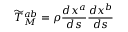<formula> <loc_0><loc_0><loc_500><loc_500>{ \widetilde { T } } _ { M } ^ { a b } = \rho { \frac { d x ^ { a } } { d s } } { \frac { d x ^ { b } } { d s } }</formula> 